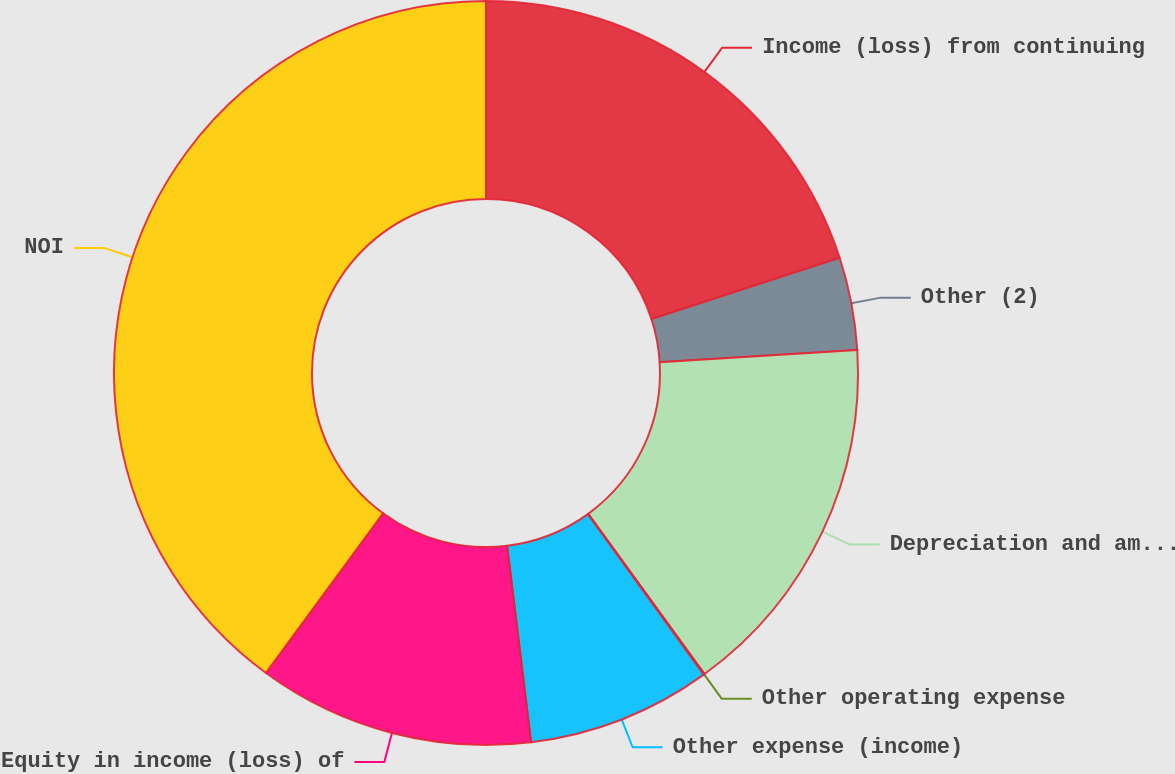<chart> <loc_0><loc_0><loc_500><loc_500><pie_chart><fcel>Income (loss) from continuing<fcel>Other (2)<fcel>Depreciation and amortization<fcel>Other operating expense<fcel>Other expense (income)<fcel>Equity in income (loss) of<fcel>NOI<nl><fcel>19.99%<fcel>4.03%<fcel>16.0%<fcel>0.04%<fcel>8.02%<fcel>12.01%<fcel>39.94%<nl></chart> 